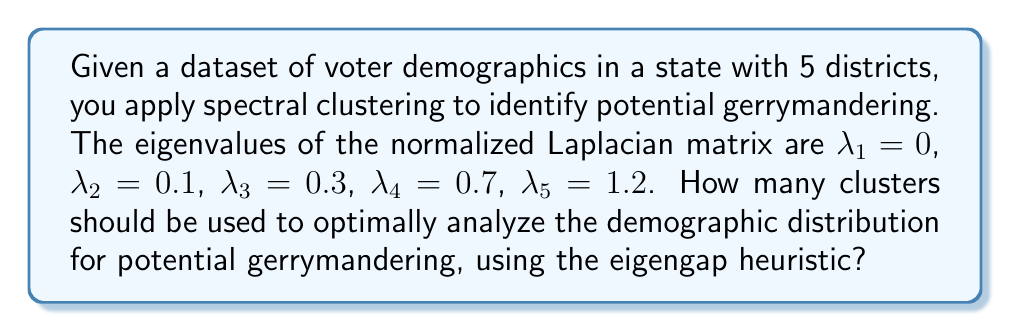What is the answer to this math problem? To determine the optimal number of clusters using the eigengap heuristic in spectral clustering, we follow these steps:

1. List the eigenvalues in ascending order:
   $\lambda_1 = 0, \lambda_2 = 0.1, \lambda_3 = 0.3, \lambda_4 = 0.7, \lambda_5 = 1.2$

2. Calculate the differences (gaps) between consecutive eigenvalues:
   $\text{gap}_1 = \lambda_2 - \lambda_1 = 0.1$
   $\text{gap}_2 = \lambda_3 - \lambda_2 = 0.2$
   $\text{gap}_3 = \lambda_4 - \lambda_3 = 0.4$
   $\text{gap}_4 = \lambda_5 - \lambda_4 = 0.5$

3. Identify the largest gap:
   The largest gap is $\text{gap}_4 = 0.5$

4. The optimal number of clusters is the index of the largest gap:
   In this case, it's 4.

This suggests that dividing the demographic data into 4 clusters would provide the most informative analysis for potential gerrymandering patterns. This clustering could reveal how the current 5 districts might be manipulated to group voters in a way that doesn't reflect natural demographic divisions.
Answer: 4 clusters 